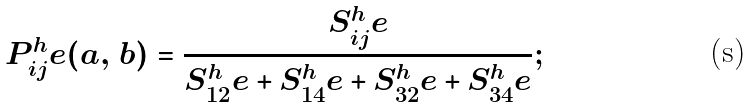Convert formula to latex. <formula><loc_0><loc_0><loc_500><loc_500>P _ { i j } ^ { h } e ( { a } , \, { b } ) = \frac { S _ { i j } ^ { h } e } { S _ { 1 2 } ^ { h } e + S _ { 1 4 } ^ { h } e + S _ { 3 2 } ^ { h } e + S _ { 3 4 } ^ { h } e } ;</formula> 